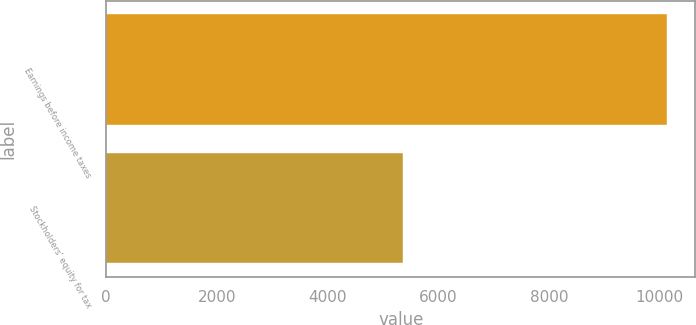Convert chart. <chart><loc_0><loc_0><loc_500><loc_500><bar_chart><fcel>Earnings before income taxes<fcel>Stockholders' equity for tax<nl><fcel>10137<fcel>5361<nl></chart> 